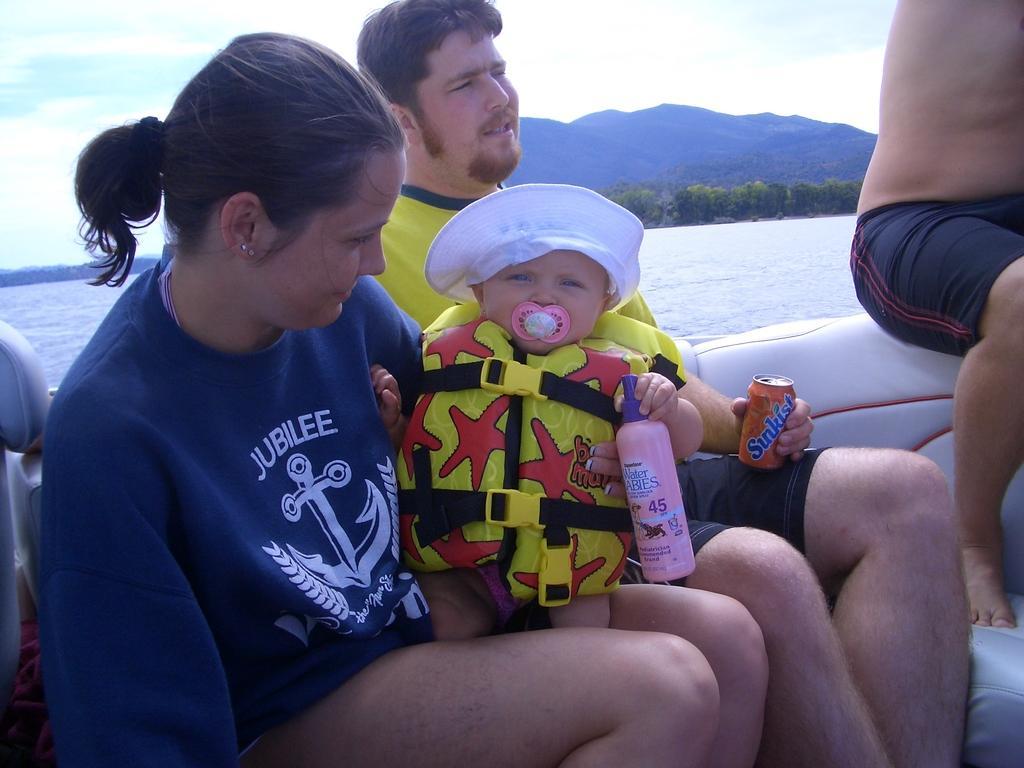In one or two sentences, can you explain what this image depicts? In this image I can see group of people sitting in the boat and the boat is on the water. In front the person is wearing blue color shirt. In the background I can see few trees in green color, mountains and the sky is in blue and white color. 